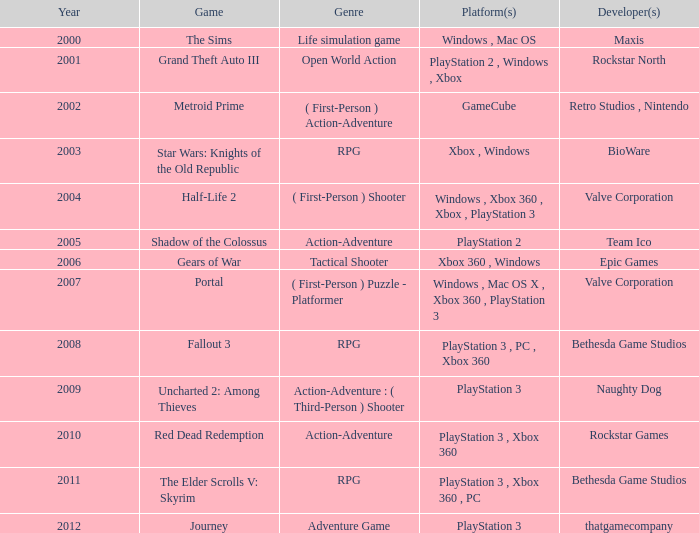What game was available in 2001? Grand Theft Auto III. 